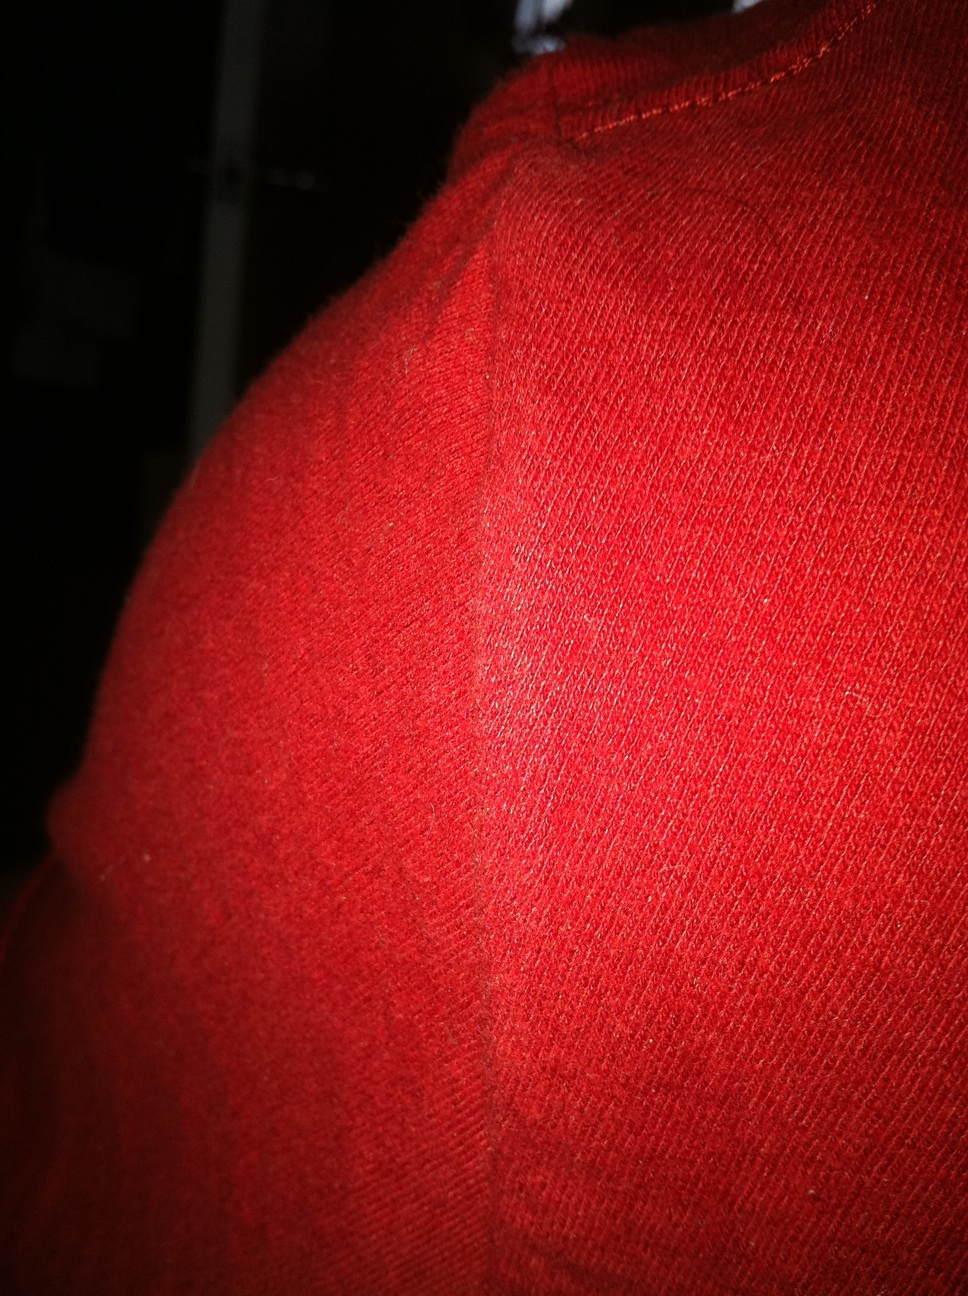Can you describe the texture visible on the surface of this fabric? The fabric in the image shows a finely ribbed texture, indicative of a knit material that typically offers some stretchability and a soft feel. 